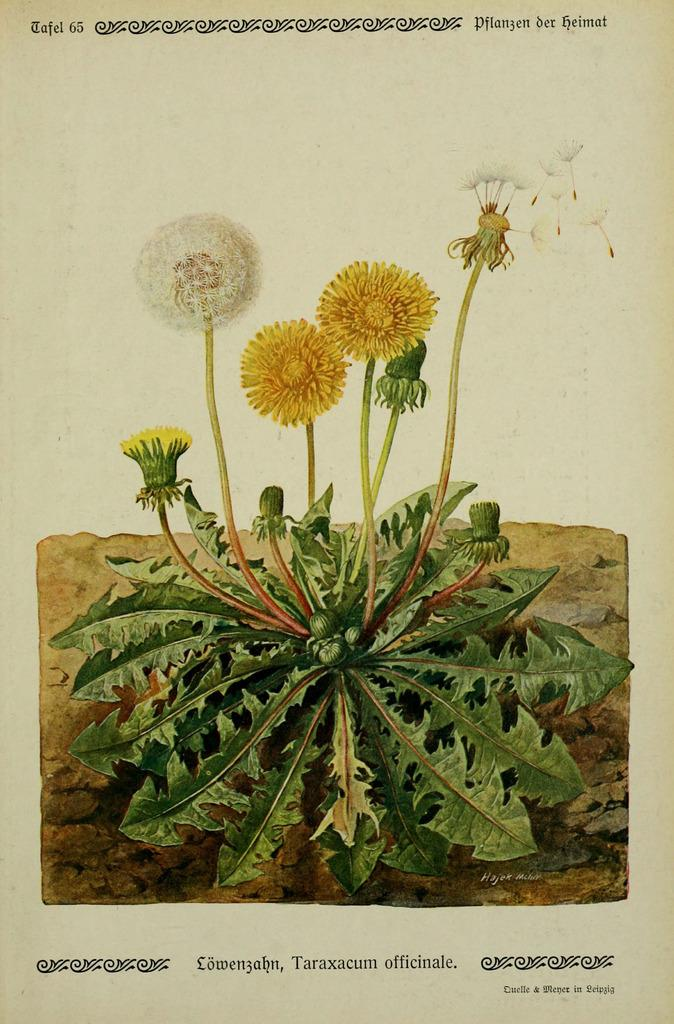What type of visual is depicted in the image? The image is a poster. What is the main subject of the poster? There is a plant with different types of flowers and leaves on the poster. What else can be seen on the poster besides the plant? There are letters and a design on the poster. Where is the tent located in the image? There is no tent present in the image. What type of vase is holding the flowers in the image? There is no vase present in the image; the flowers are part of the plant depicted on the poster. 